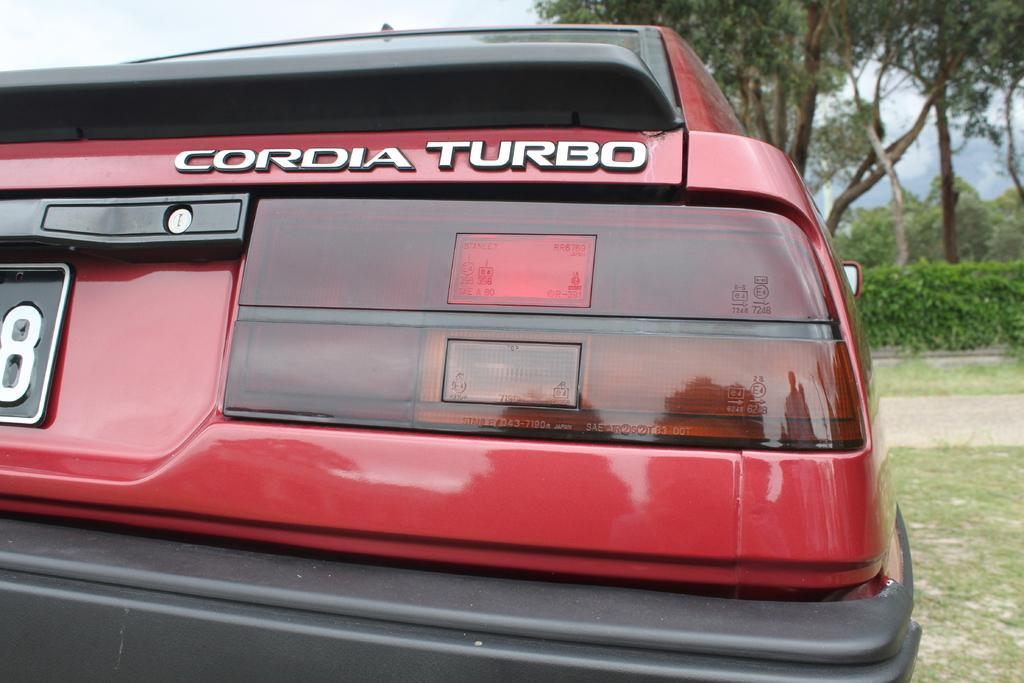Provide a one-sentence caption for the provided image. the back of a red CORDIA TURBO car parked and not on the road. 